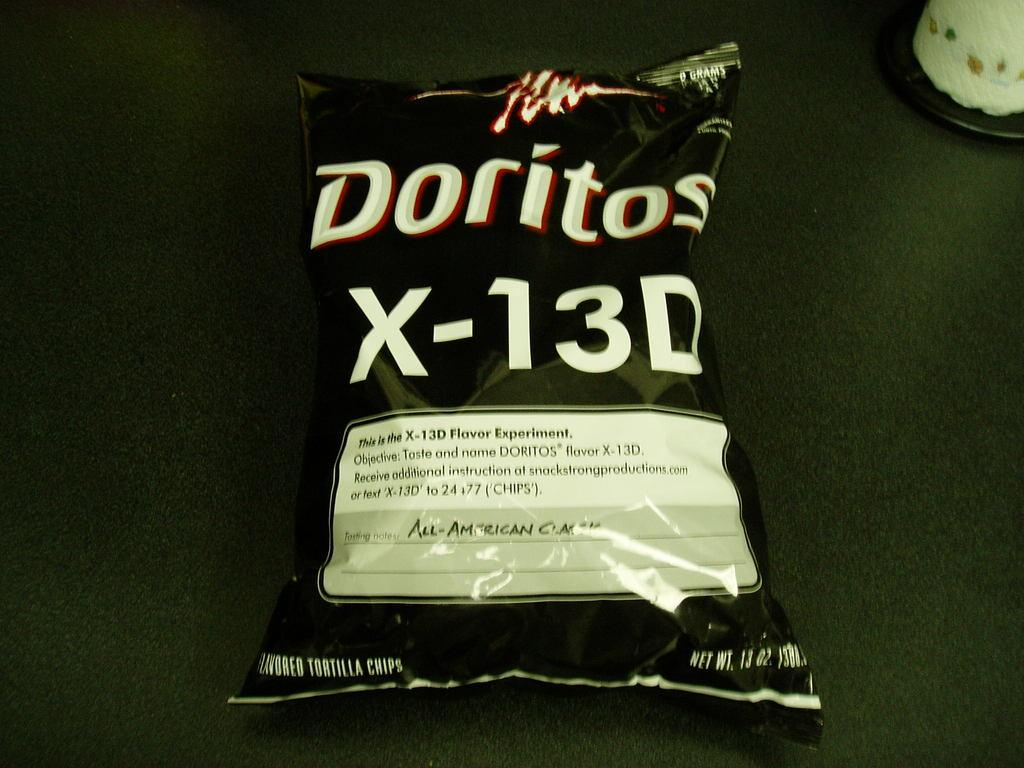<image>
Relay a brief, clear account of the picture shown. a bag of chips that has the letter x on it 